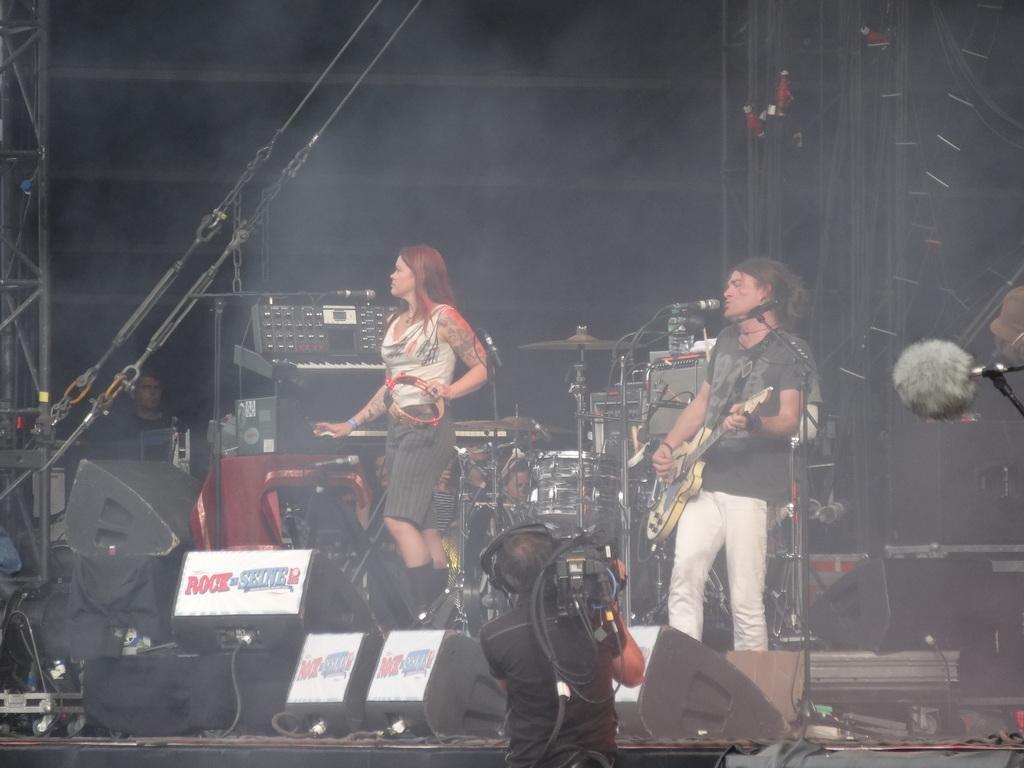Describe this image in one or two sentences. This image is clicked at a stage performance. In the middle there is a woman she wear t shirt and trouser her hair is short she is playing a musical instrument. On the right there is a man he wear t shirt and trouser he is playing guitar. In the middle there is a man he is holding camera and there are speakers and mic. In the back ground there are drums, person and some other musical instruments. 